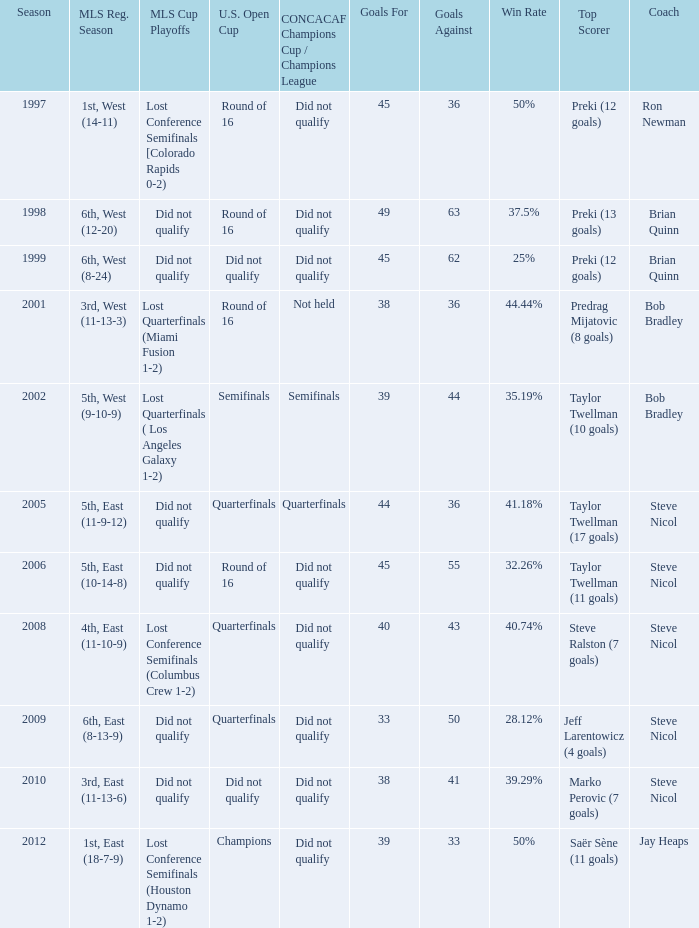Could you parse the entire table as a dict? {'header': ['Season', 'MLS Reg. Season', 'MLS Cup Playoffs', 'U.S. Open Cup', 'CONCACAF Champions Cup / Champions League', 'Goals For', 'Goals Against', 'Win Rate', 'Top Scorer', 'Coach'], 'rows': [['1997', '1st, West (14-11)', 'Lost Conference Semifinals [Colorado Rapids 0-2)', 'Round of 16', 'Did not qualify', '45', '36', '50%', 'Preki (12 goals)', 'Ron Newman'], ['1998', '6th, West (12-20)', 'Did not qualify', 'Round of 16', 'Did not qualify', '49', '63', '37.5%', 'Preki (13 goals)', 'Brian Quinn'], ['1999', '6th, West (8-24)', 'Did not qualify', 'Did not qualify', 'Did not qualify', '45', '62', '25%', 'Preki (12 goals)', 'Brian Quinn'], ['2001', '3rd, West (11-13-3)', 'Lost Quarterfinals (Miami Fusion 1-2)', 'Round of 16', 'Not held', '38', '36', '44.44%', 'Predrag Mijatovic (8 goals)', 'Bob Bradley'], ['2002', '5th, West (9-10-9)', 'Lost Quarterfinals ( Los Angeles Galaxy 1-2)', 'Semifinals', 'Semifinals', '39', '44', '35.19%', 'Taylor Twellman (10 goals)', 'Bob Bradley'], ['2005', '5th, East (11-9-12)', 'Did not qualify', 'Quarterfinals', 'Quarterfinals', '44', '36', '41.18%', 'Taylor Twellman (17 goals)', 'Steve Nicol'], ['2006', '5th, East (10-14-8)', 'Did not qualify', 'Round of 16', 'Did not qualify', '45', '55', '32.26%', 'Taylor Twellman (11 goals)', 'Steve Nicol'], ['2008', '4th, East (11-10-9)', 'Lost Conference Semifinals (Columbus Crew 1-2)', 'Quarterfinals', 'Did not qualify', '40', '43', '40.74%', 'Steve Ralston (7 goals)', 'Steve Nicol'], ['2009', '6th, East (8-13-9)', 'Did not qualify', 'Quarterfinals', 'Did not qualify', '33', '50', '28.12%', 'Jeff Larentowicz (4 goals)', 'Steve Nicol'], ['2010', '3rd, East (11-13-6)', 'Did not qualify', 'Did not qualify', 'Did not qualify', '38', '41', '39.29%', 'Marko Perovic (7 goals)', 'Steve Nicol'], ['2012', '1st, East (18-7-9)', 'Lost Conference Semifinals (Houston Dynamo 1-2)', 'Champions', 'Did not qualify', '39', '33', '50%', 'Saër Sène (11 goals)', 'Jay Heaps']]} How did the team place when they did not qualify for the Concaf Champions Cup but made it to Round of 16 in the U.S. Open Cup? Lost Conference Semifinals [Colorado Rapids 0-2), Did not qualify, Did not qualify. 